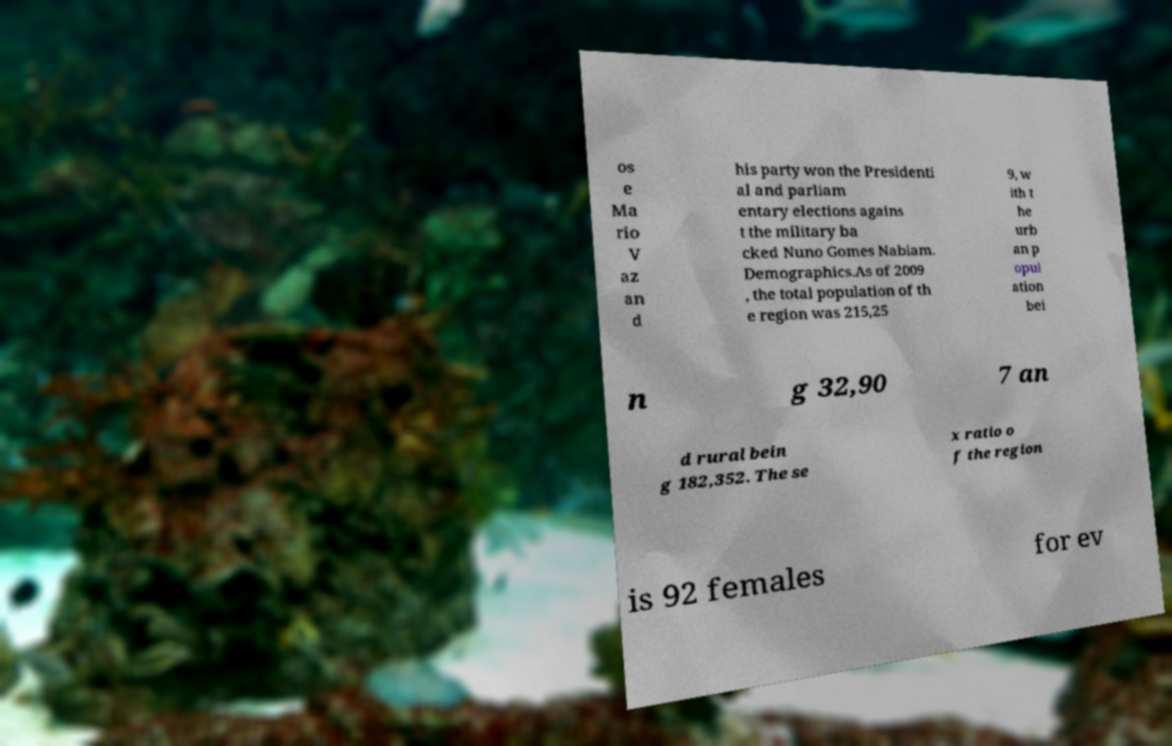Can you read and provide the text displayed in the image?This photo seems to have some interesting text. Can you extract and type it out for me? os e Ma rio V az an d his party won the Presidenti al and parliam entary elections agains t the military ba cked Nuno Gomes Nabiam. Demographics.As of 2009 , the total population of th e region was 215,25 9, w ith t he urb an p opul ation bei n g 32,90 7 an d rural bein g 182,352. The se x ratio o f the region is 92 females for ev 